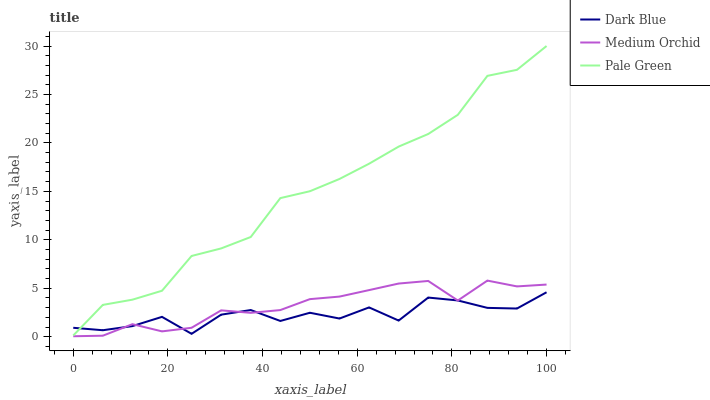Does Dark Blue have the minimum area under the curve?
Answer yes or no. Yes. Does Pale Green have the maximum area under the curve?
Answer yes or no. Yes. Does Medium Orchid have the minimum area under the curve?
Answer yes or no. No. Does Medium Orchid have the maximum area under the curve?
Answer yes or no. No. Is Medium Orchid the smoothest?
Answer yes or no. Yes. Is Dark Blue the roughest?
Answer yes or no. Yes. Is Pale Green the smoothest?
Answer yes or no. No. Is Pale Green the roughest?
Answer yes or no. No. Does Medium Orchid have the lowest value?
Answer yes or no. Yes. Does Pale Green have the lowest value?
Answer yes or no. No. Does Pale Green have the highest value?
Answer yes or no. Yes. Does Medium Orchid have the highest value?
Answer yes or no. No. Is Medium Orchid less than Pale Green?
Answer yes or no. Yes. Is Pale Green greater than Medium Orchid?
Answer yes or no. Yes. Does Dark Blue intersect Medium Orchid?
Answer yes or no. Yes. Is Dark Blue less than Medium Orchid?
Answer yes or no. No. Is Dark Blue greater than Medium Orchid?
Answer yes or no. No. Does Medium Orchid intersect Pale Green?
Answer yes or no. No. 